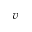<formula> <loc_0><loc_0><loc_500><loc_500>v</formula> 